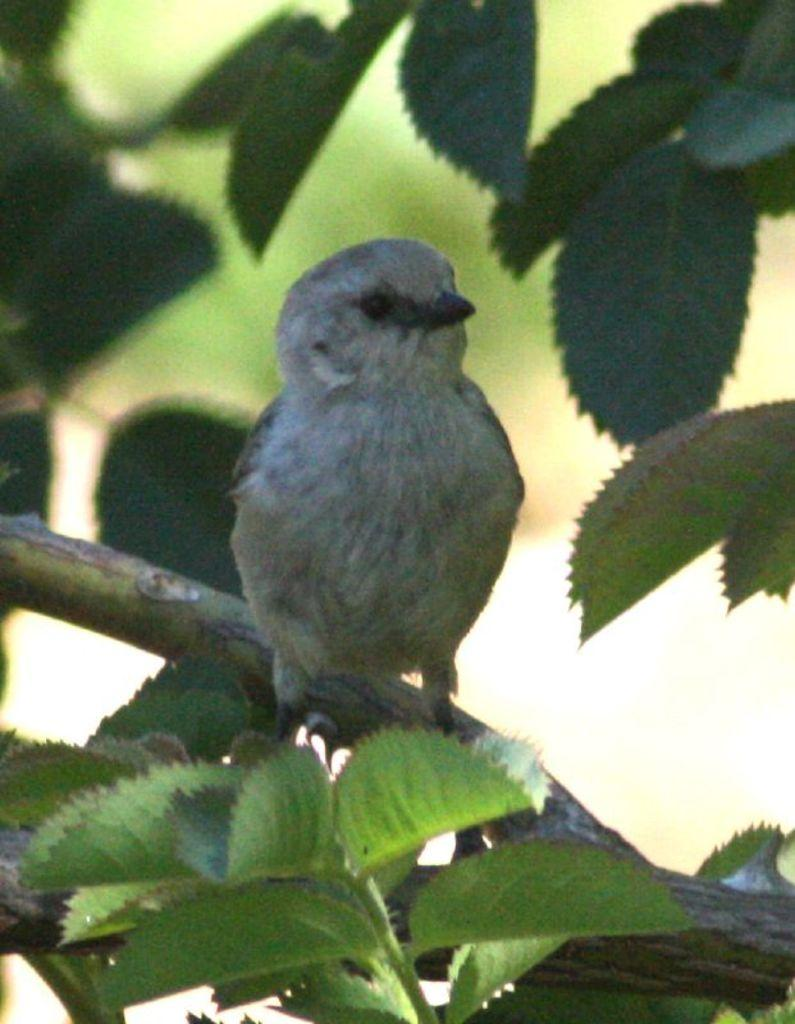What type of animal can be seen in the image? There is a bird in the image. Where is the bird located? The bird is on a branch of a tree in the image. What is the bird sitting on? The bird is sitting on a branch of a tree. What can be seen around the bird? There are leaves visible around the bird. What type of star can be seen in the image? There is no star visible in the image; it features a bird on a tree branch with leaves around it. How does the bird stretch in the image? The bird is not stretching in the image; it is sitting on a branch with its wings close to its body. 